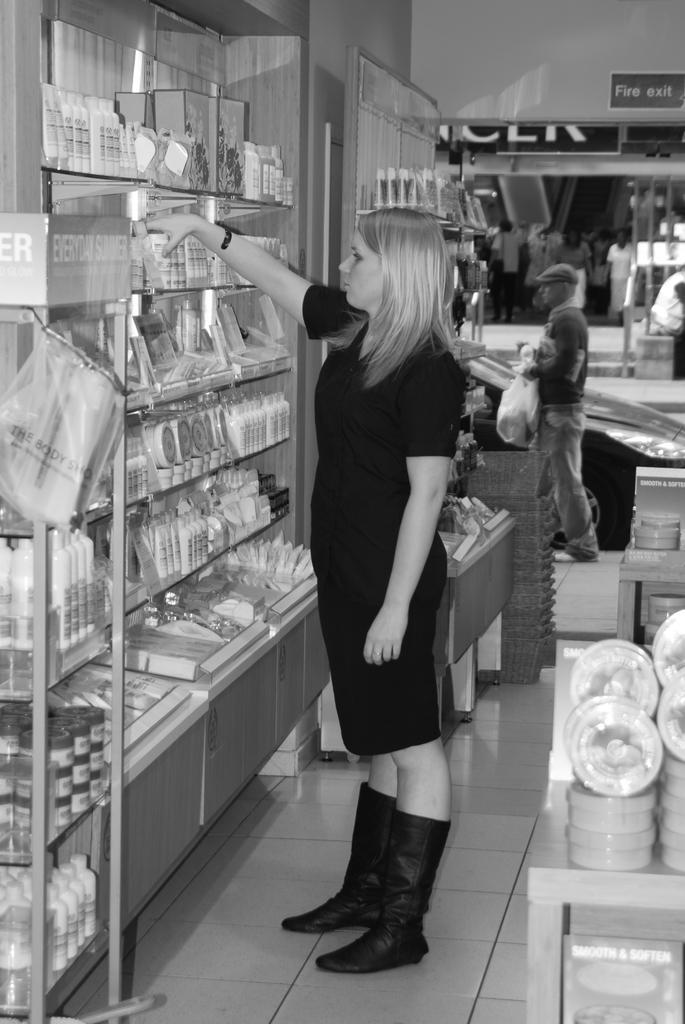Describe this image in one or two sentences. In this image, I can see glass racks in which some objects are placed and a group of people on the floor. In the background, I can see a wall, board and some objects. This image taken, maybe in a shop. 